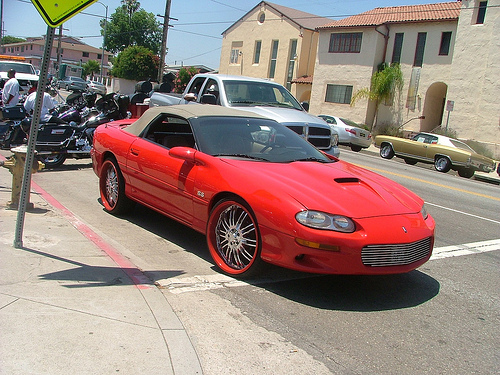<image>
Is there a car behind the truck? Yes. From this viewpoint, the car is positioned behind the truck, with the truck partially or fully occluding the car. 